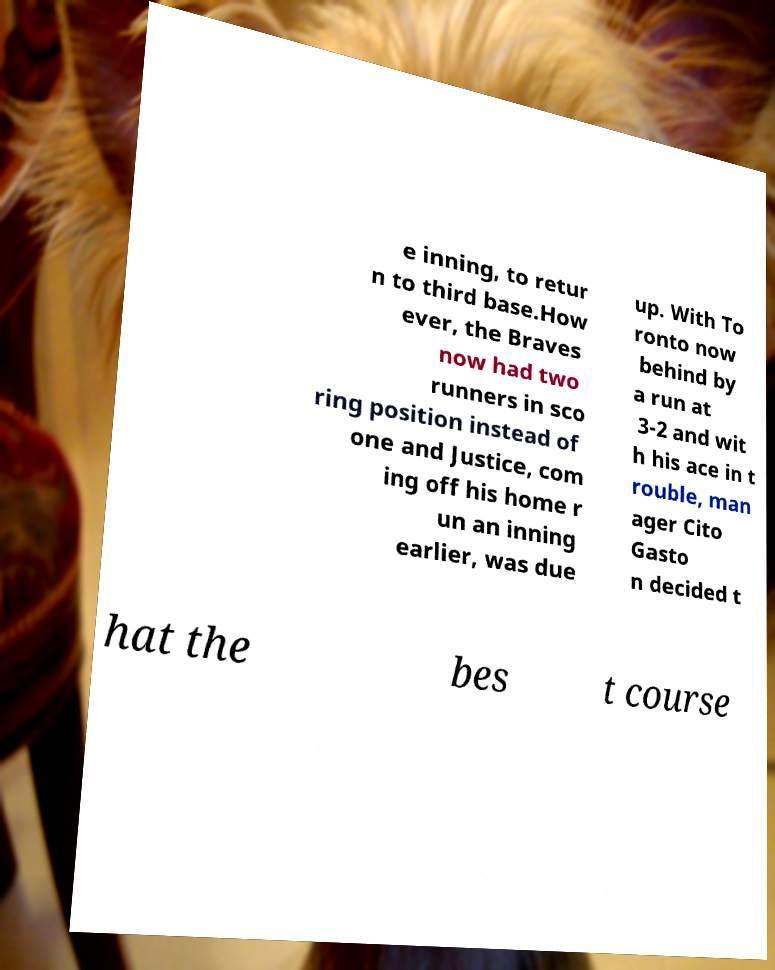Could you extract and type out the text from this image? e inning, to retur n to third base.How ever, the Braves now had two runners in sco ring position instead of one and Justice, com ing off his home r un an inning earlier, was due up. With To ronto now behind by a run at 3-2 and wit h his ace in t rouble, man ager Cito Gasto n decided t hat the bes t course 